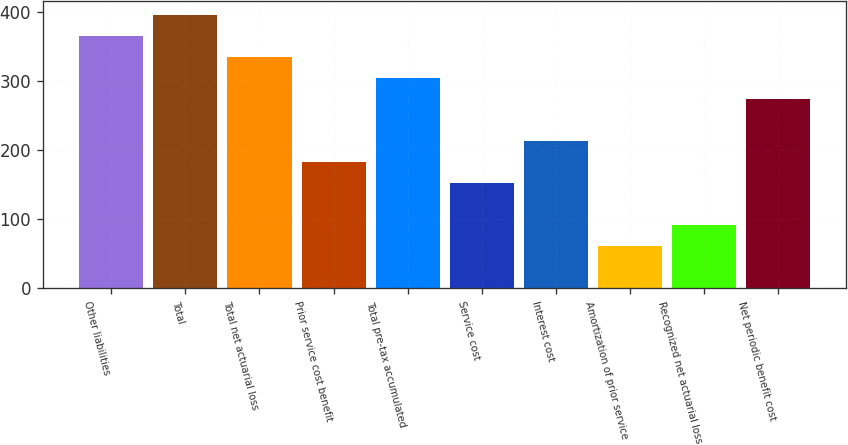<chart> <loc_0><loc_0><loc_500><loc_500><bar_chart><fcel>Other liabilities<fcel>Total<fcel>Total net actuarial loss<fcel>Prior service cost benefit<fcel>Total pre-tax accumulated<fcel>Service cost<fcel>Interest cost<fcel>Amortization of prior service<fcel>Recognized net actuarial loss<fcel>Net periodic benefit cost<nl><fcel>366.26<fcel>396.74<fcel>335.78<fcel>183.38<fcel>305.3<fcel>152.9<fcel>213.86<fcel>61.46<fcel>91.94<fcel>274.82<nl></chart> 